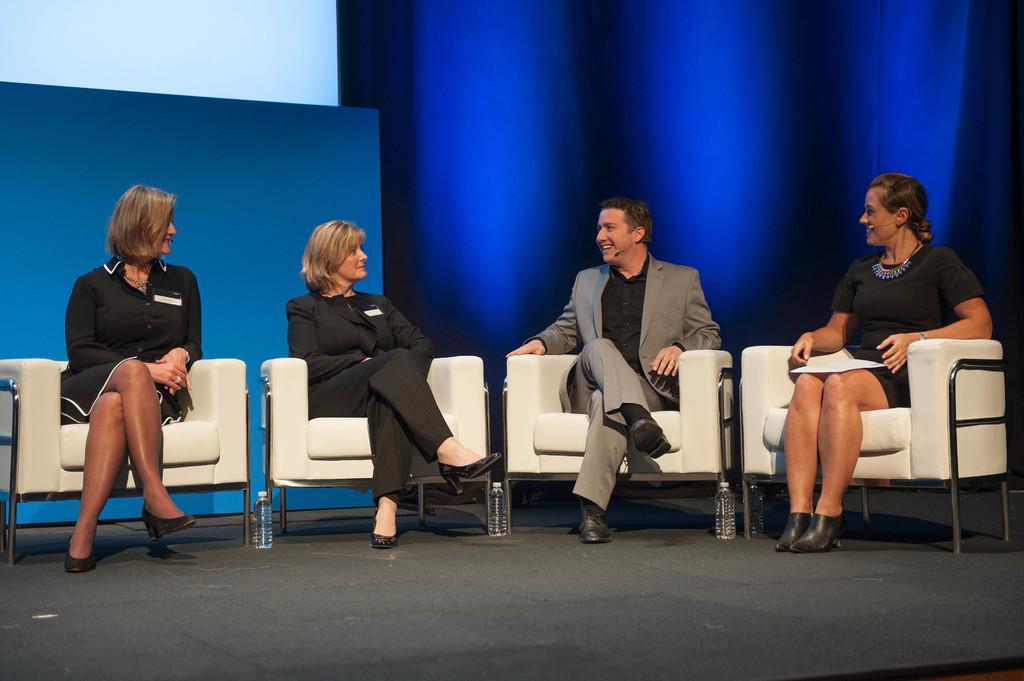Can you describe this image briefly? In this picture we can observe four members sitting in the white color chairs. Three of them are women and the one of them is a man wearing a coat. In the background we can observe blue color curtain. 